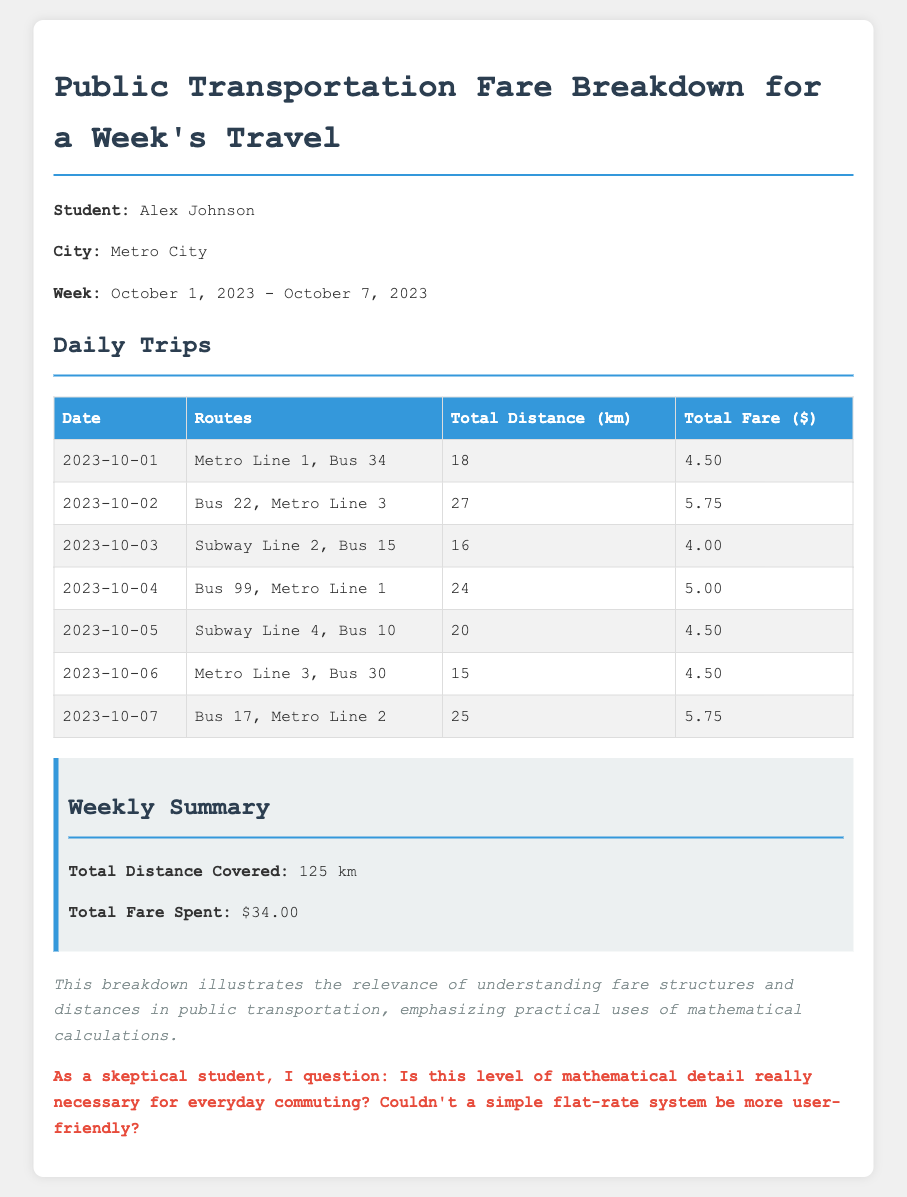What is the total distance covered? The total distance covered is listed in the weekly summary section of the document, which states 125 km.
Answer: 125 km How much was spent on fare on 2023-10-03? The fare for 2023-10-03 is provided in the daily trips table under the associated date, showing $4.00.
Answer: $4.00 Which routes were taken on 2023-10-05? The daily trips table indicates that on 2023-10-05, Alex traveled on Subway Line 4 and Bus 10.
Answer: Subway Line 4, Bus 10 What is the total fare spent during the week? The total fare spent is detailed in the weekly summary, which shows the amount as $34.00.
Answer: $34.00 Which day had the longest total distance traveled? By examining the daily trips table, on 2023-10-02, the distance was 27 km, which is the longest of the week.
Answer: 27 km What is stated in the notes section of the document? The notes section provides insights on the relevance of understanding fare structures and distances, emphasizing practical uses.
Answer: Understanding fare structures On what day was Bus 99 used? According to the daily trips table, Bus 99 was used on 2023-10-04 as part of the travel routes.
Answer: 2023-10-04 How many routes were taken on 2023-10-06? The number of routes taken on 2023-10-06 is listed in the daily trips table, which mentions two routes: Metro Line 3 and Bus 30.
Answer: 2 